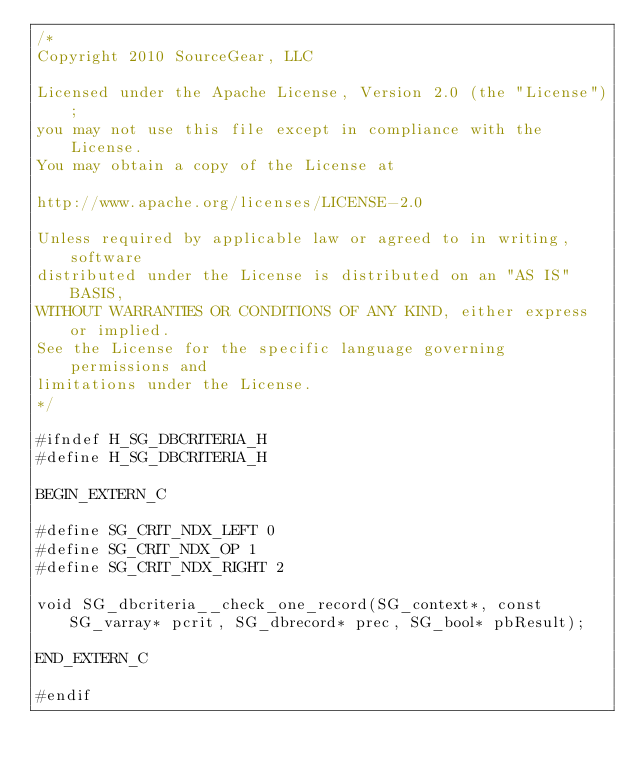<code> <loc_0><loc_0><loc_500><loc_500><_C_>/*
Copyright 2010 SourceGear, LLC

Licensed under the Apache License, Version 2.0 (the "License");
you may not use this file except in compliance with the License.
You may obtain a copy of the License at

http://www.apache.org/licenses/LICENSE-2.0

Unless required by applicable law or agreed to in writing, software
distributed under the License is distributed on an "AS IS" BASIS,
WITHOUT WARRANTIES OR CONDITIONS OF ANY KIND, either express or implied.
See the License for the specific language governing permissions and
limitations under the License.
*/

#ifndef H_SG_DBCRITERIA_H
#define H_SG_DBCRITERIA_H

BEGIN_EXTERN_C

#define SG_CRIT_NDX_LEFT 0
#define SG_CRIT_NDX_OP 1
#define SG_CRIT_NDX_RIGHT 2

void SG_dbcriteria__check_one_record(SG_context*, const SG_varray* pcrit, SG_dbrecord* prec, SG_bool* pbResult);

END_EXTERN_C

#endif
</code> 